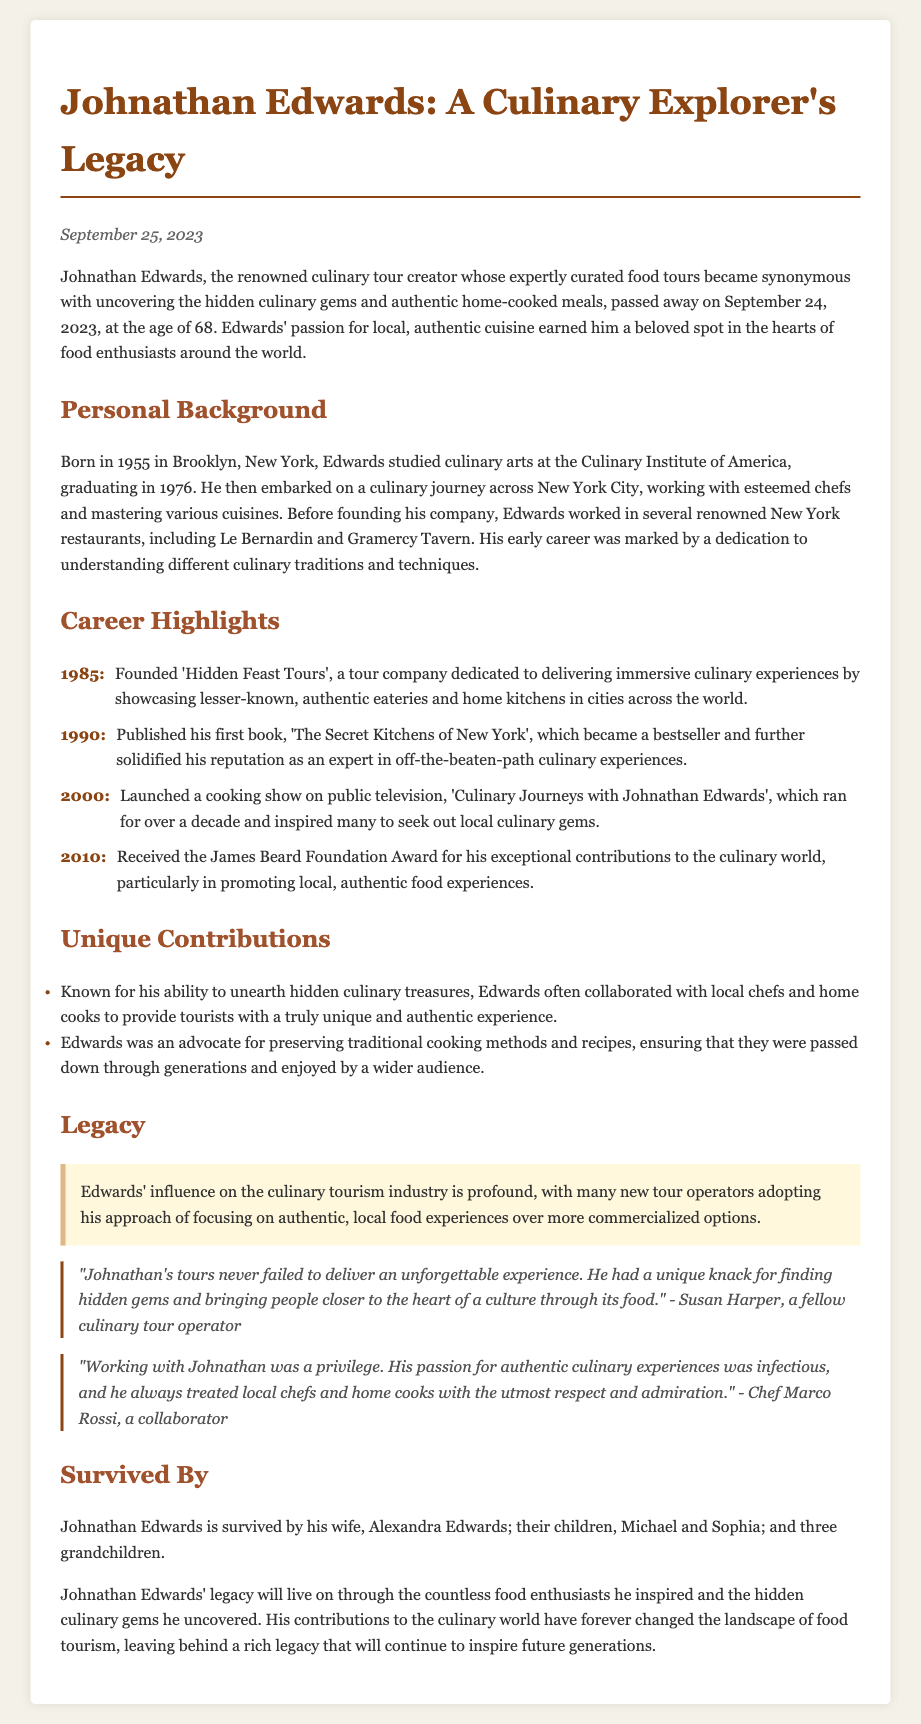What year was Johnathan Edwards born? The obituary states Johnathan Edwards was born in 1955.
Answer: 1955 What was the name of the cooking show launched by Johnathan Edwards? The show launched in 2000 is titled 'Culinary Journeys with Johnathan Edwards'.
Answer: Culinary Journeys with Johnathan Edwards What award did Johnathan Edwards receive in 2010? The document mentions he received the James Beard Foundation Award in 2010.
Answer: James Beard Foundation Award Who is quoted as saying, "Johnathan's tours never failed to deliver an unforgettable experience"? The quote is attributed to Susan Harper, a fellow culinary tour operator.
Answer: Susan Harper How many grandchildren did Johnathan Edwards have? The obituary states that he had three grandchildren.
Answer: three What was the primary focus of Edwards' tour company 'Hidden Feast Tours'? The company was dedicated to delivering immersive culinary experiences by showcasing lesser-known eateries.
Answer: lesser-known eateries In what city did Johnathan Edwards study culinary arts? According to the document, he studied culinary arts in New York.
Answer: New York Which two renowned New York restaurants did Edwards work in before founding his company? The document lists Le Bernardin and Gramercy Tavern as restaurants where he worked.
Answer: Le Bernardin and Gramercy Tavern 